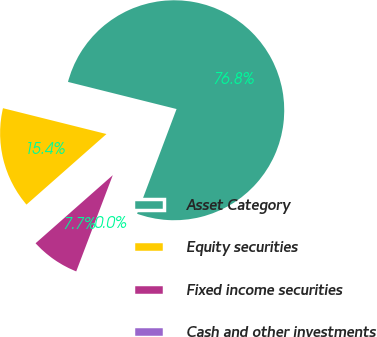Convert chart. <chart><loc_0><loc_0><loc_500><loc_500><pie_chart><fcel>Asset Category<fcel>Equity securities<fcel>Fixed income securities<fcel>Cash and other investments<nl><fcel>76.84%<fcel>15.4%<fcel>7.72%<fcel>0.04%<nl></chart> 